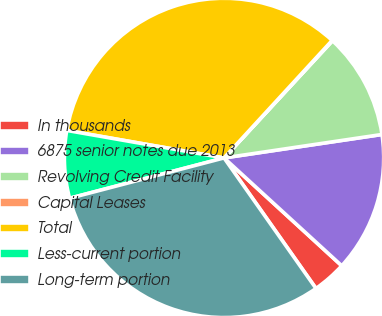Convert chart. <chart><loc_0><loc_0><loc_500><loc_500><pie_chart><fcel>In thousands<fcel>6875 senior notes due 2013<fcel>Revolving Credit Facility<fcel>Capital Leases<fcel>Total<fcel>Less-current portion<fcel>Long-term portion<nl><fcel>3.43%<fcel>14.15%<fcel>10.77%<fcel>0.05%<fcel>34.08%<fcel>6.82%<fcel>30.7%<nl></chart> 